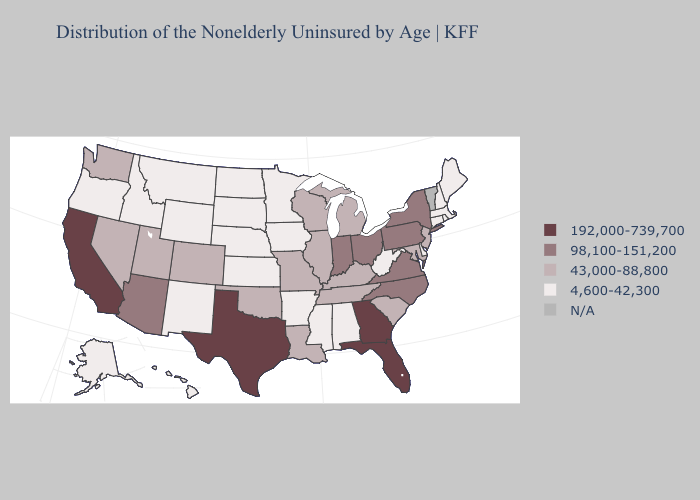What is the value of Maryland?
Be succinct. 43,000-88,800. Which states have the lowest value in the South?
Give a very brief answer. Alabama, Arkansas, Delaware, Mississippi, West Virginia. What is the highest value in states that border Oklahoma?
Be succinct. 192,000-739,700. Which states have the lowest value in the Northeast?
Write a very short answer. Connecticut, Maine, Massachusetts, New Hampshire, Rhode Island. What is the value of Nebraska?
Answer briefly. 4,600-42,300. What is the lowest value in states that border Rhode Island?
Give a very brief answer. 4,600-42,300. Name the states that have a value in the range 192,000-739,700?
Short answer required. California, Florida, Georgia, Texas. Name the states that have a value in the range N/A?
Give a very brief answer. Vermont. What is the value of South Dakota?
Be succinct. 4,600-42,300. Name the states that have a value in the range 98,100-151,200?
Short answer required. Arizona, Indiana, New York, North Carolina, Ohio, Pennsylvania, Virginia. Does Massachusetts have the lowest value in the Northeast?
Answer briefly. Yes. Does California have the highest value in the USA?
Quick response, please. Yes. Does the first symbol in the legend represent the smallest category?
Short answer required. No. 